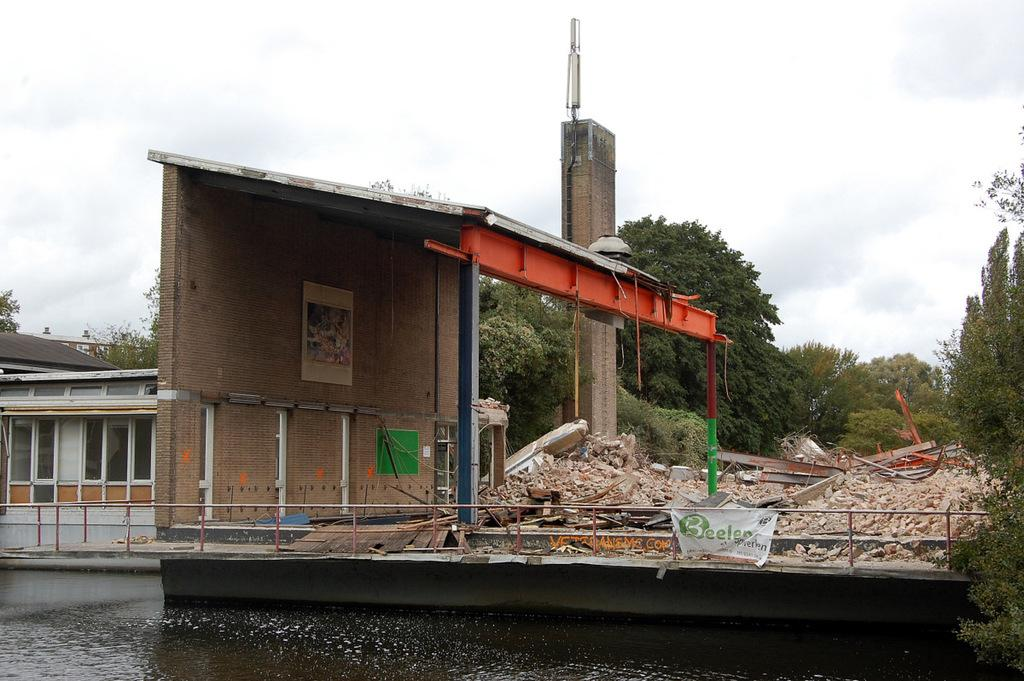What type of structure is present in the image? There is a building in the image. What other natural elements can be seen in the image? There are trees and water visible in the image. What is visible in the background of the image? The sky is visible in the background of the image. Can you see the governor jumping at the airport in the image? There is no governor or airport present in the image, and no one is jumping. 